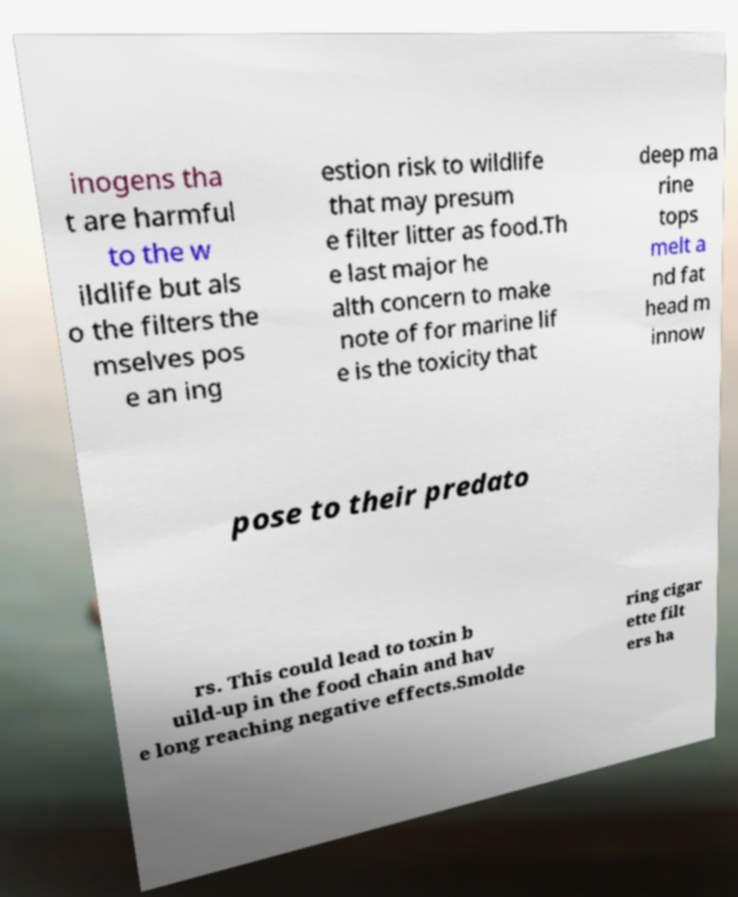For documentation purposes, I need the text within this image transcribed. Could you provide that? inogens tha t are harmful to the w ildlife but als o the filters the mselves pos e an ing estion risk to wildlife that may presum e filter litter as food.Th e last major he alth concern to make note of for marine lif e is the toxicity that deep ma rine tops melt a nd fat head m innow pose to their predato rs. This could lead to toxin b uild-up in the food chain and hav e long reaching negative effects.Smolde ring cigar ette filt ers ha 